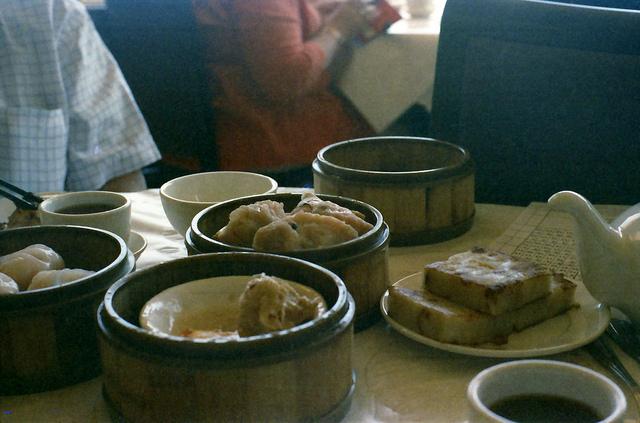What is in the black pot?
Quick response, please. Tea. What type of liquid is in the cups?
Quick response, please. Coffee. What type of fish are in the wooden bowl?
Write a very short answer. Dumplings. What type of meal is this?
Be succinct. Lunch. What color is the man's shirt?
Keep it brief. White. 